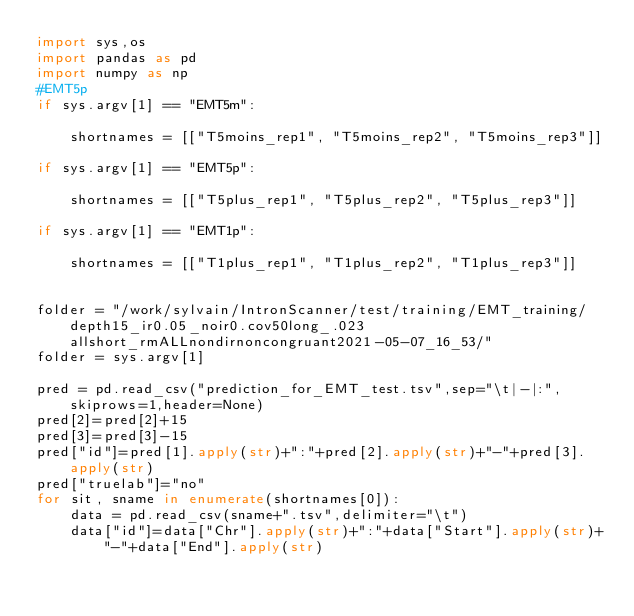Convert code to text. <code><loc_0><loc_0><loc_500><loc_500><_Python_>import sys,os
import pandas as pd
import numpy as np
#EMT5p
if sys.argv[1] == "EMT5m":

    shortnames = [["T5moins_rep1", "T5moins_rep2", "T5moins_rep3"]]

if sys.argv[1] == "EMT5p":

    shortnames = [["T5plus_rep1", "T5plus_rep2", "T5plus_rep3"]]

if sys.argv[1] == "EMT1p":

    shortnames = [["T1plus_rep1", "T1plus_rep2", "T1plus_rep3"]]


folder = "/work/sylvain/IntronScanner/test/training/EMT_training/depth15_ir0.05_noir0.cov50long_.023allshort_rmALLnondirnoncongruant2021-05-07_16_53/"
folder = sys.argv[1]

pred = pd.read_csv("prediction_for_EMT_test.tsv",sep="\t|-|:",skiprows=1,header=None)
pred[2]=pred[2]+15
pred[3]=pred[3]-15
pred["id"]=pred[1].apply(str)+":"+pred[2].apply(str)+"-"+pred[3].apply(str)
pred["truelab"]="no"
for sit, sname in enumerate(shortnames[0]):
    data = pd.read_csv(sname+".tsv",delimiter="\t")
    data["id"]=data["Chr"].apply(str)+":"+data["Start"].apply(str)+"-"+data["End"].apply(str)</code> 